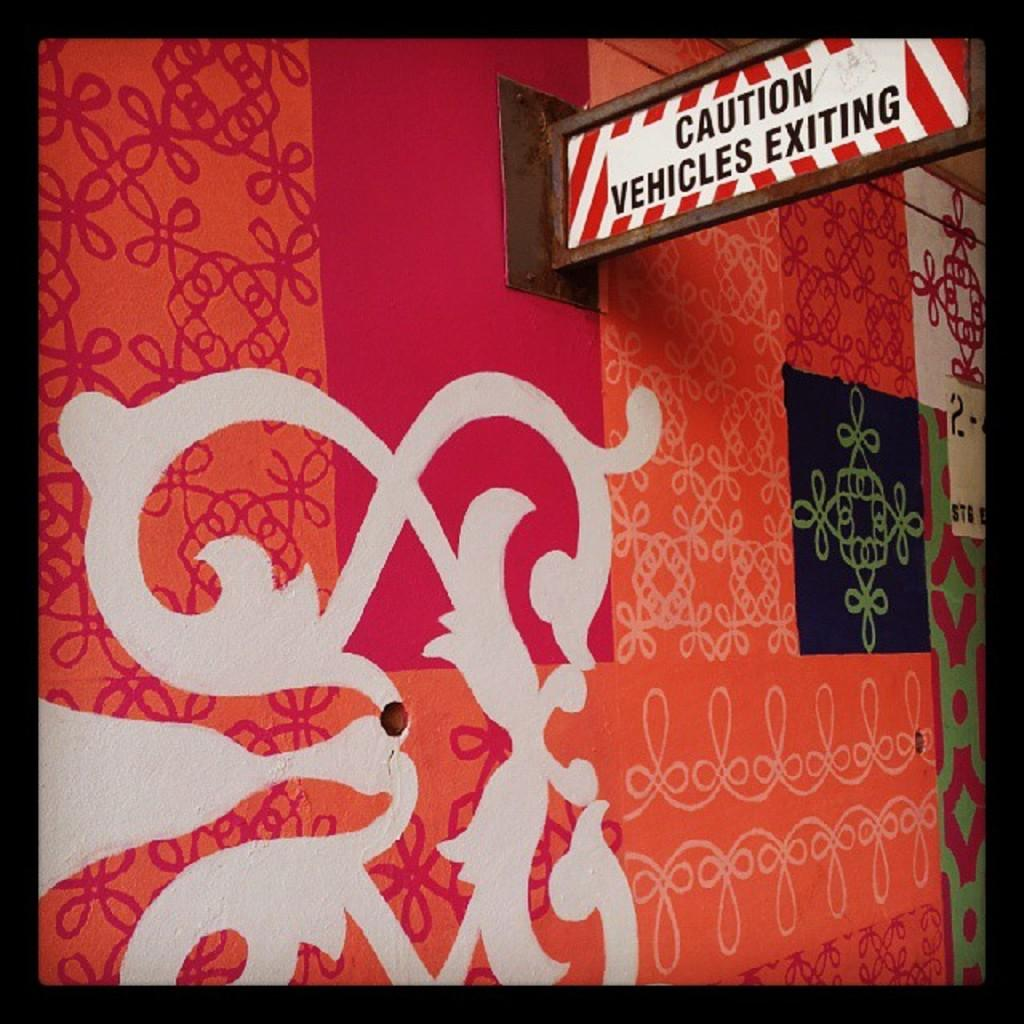<image>
Write a terse but informative summary of the picture. A sign warning about exiting vehicles sticks out from a garishly decorated wall. 